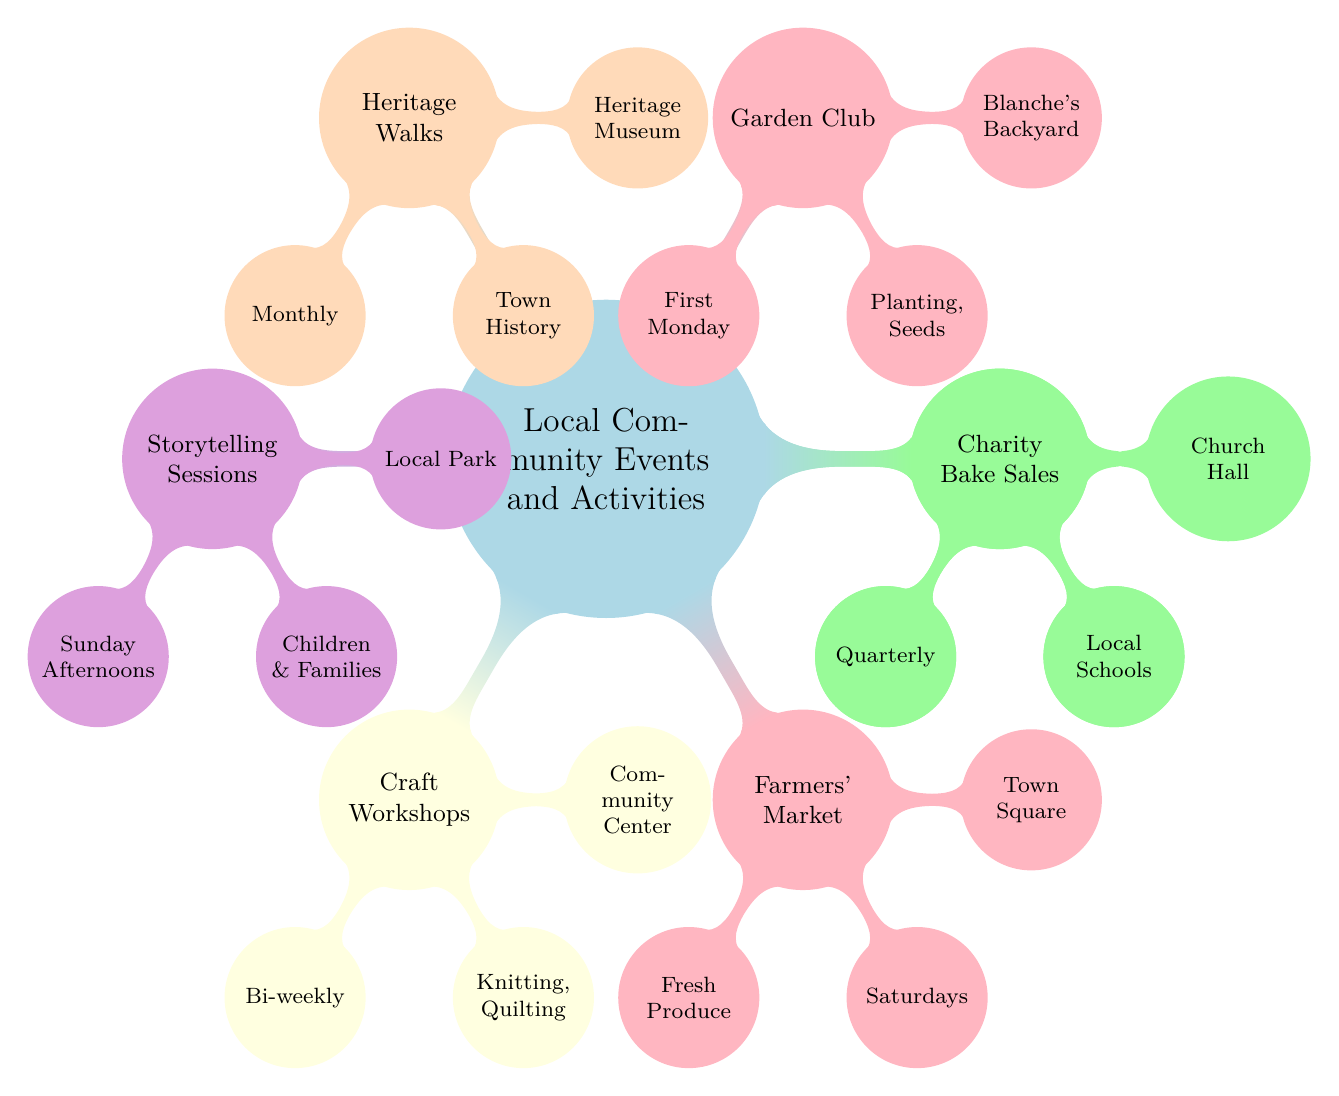What is the frequency of the Book Club? The Book Club node has a child node indicating its frequency, which is found by looking directly under the Book Club node. It states "Monthly."
Answer: Monthly Where are the Farmers' Market events held? The Farmers' Market node contains a child node that specifies its location. When examining it, it clearly states "Town Square."
Answer: Town Square What type of literature is featured in the Book Club? By examining the Book Club node, there's a child node that specifies the genre of literature discussed. The node indicates "Classic Literature."
Answer: Classic Literature How often do Heritage Walks occur? To find the answer, one must look at the Heritage Walks node, which contains a direct child node indicating how often the walks are held. This node states "Monthly."
Answer: Monthly What is the schedule for the Garden Club? The Garden Club node has a child node detailing its schedule, which indicates when this event is taking place. The node states "First Monday of the Month."
Answer: First Monday Which host organizes the Craft Workshops? By checking the Craft Workshops node, there is a child node that points out who is responsible for hosting these events. It specifies "Community Center."
Answer: Community Center What types of activities does the Garden Club focus on? Upon reviewing the Garden Club node, it includes a child node listing specific activities organized by the club. It mentions "Planting, Seed Exchange."
Answer: Planting, Seed Exchange How frequently do Charity Bake Sales take place? The Charity Bake Sales node features a child node providing information about how often these sales are conducted. The node states "Quarterly."
Answer: Quarterly Who benefits from the Charity Bake Sales? To answer this question, one must examine the Charity Bake Sales node, which includes a child node indicating the beneficiary of the funds raised. This node specifies "Local Schools & Shelters."
Answer: Local Schools & Shelters 